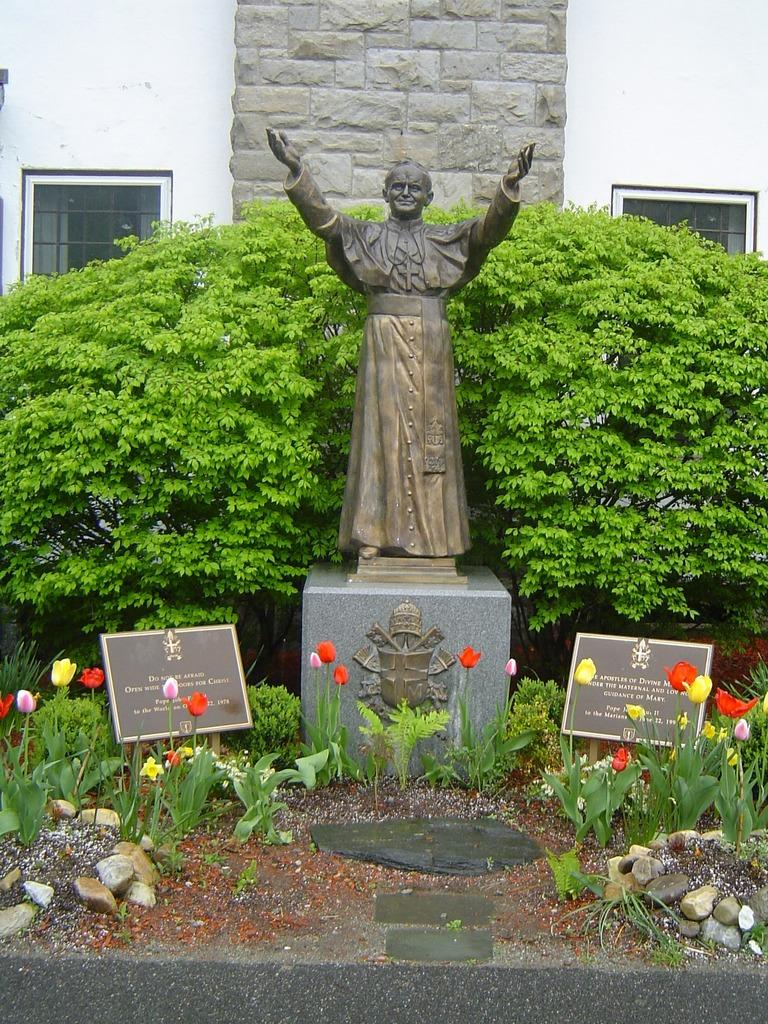What is the main subject of the image? There is a sculpture of a person in the image. What other objects can be seen in the image? There are boards, plants, flowers, grass, and trees in the image. Can you describe the background of the image? There is a wall with windows in the background of the image. What type of kettle is being used to water the flowers in the image? There is no kettle present in the image; it only features a sculpture, boards, plants, flowers, grass, trees, and a wall with windows in the background. 